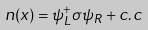Convert formula to latex. <formula><loc_0><loc_0><loc_500><loc_500>n ( x ) = \psi _ { L } ^ { + } \sigma \psi _ { R } + c . c</formula> 